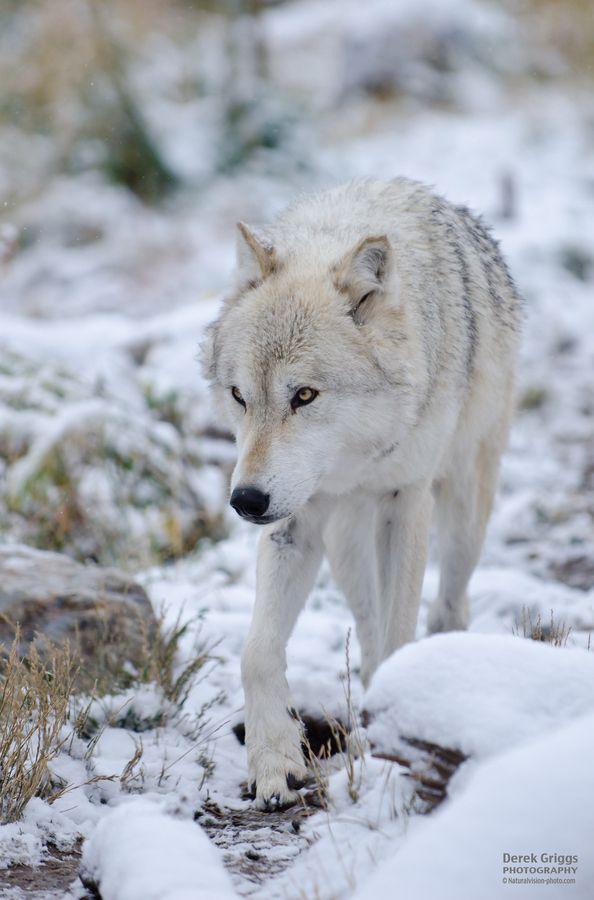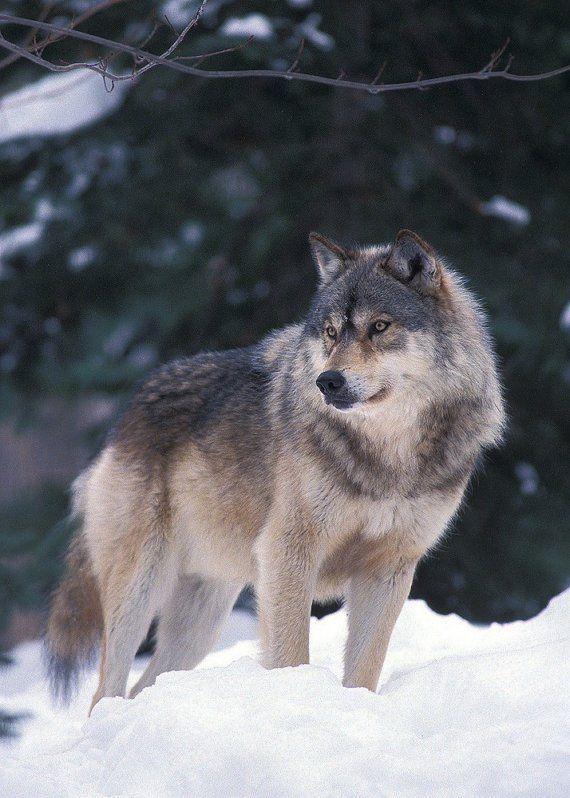The first image is the image on the left, the second image is the image on the right. Evaluate the accuracy of this statement regarding the images: "the wolf on the right image is sitting". Is it true? Answer yes or no. No. 